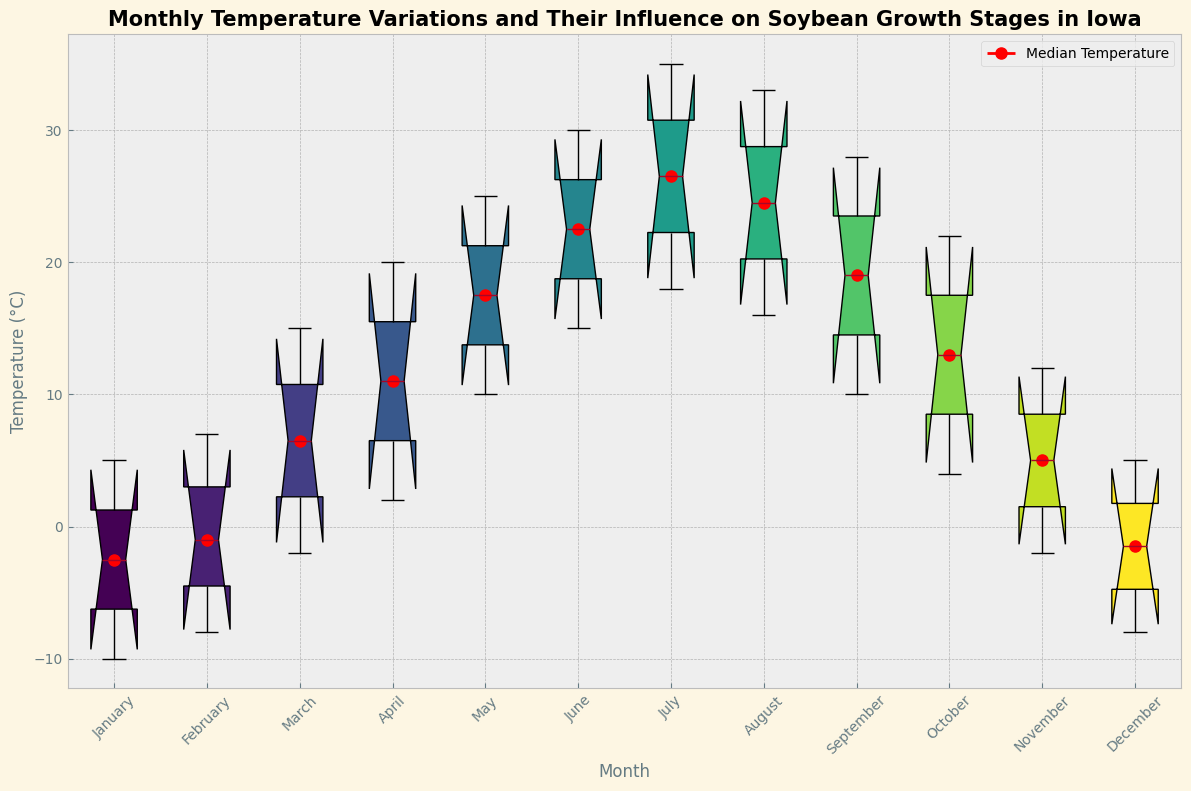What is the median temperature in July? The median temperature value can be directly found on the figure at the intersection of July and the red dot meant to indicate the median.
Answer: 26.5°C Which month has the highest maximum temperature, and what is that temperature? Look for the month with the highest point on the vertical axis corresponding to the box plot with the highest maximum box value.
Answer: July, 35.0°C In which month do the temperatures range from approximately -10°C to around 5°C? Identify the month with a box plot range showing minimum and maximum values spanning from about -10°C to 5°C.
Answer: January How does the temperature variation in June compare to that in September regarding the interquartile range (IQR)? The IQR is the range between the first quartile (bottom of the box) and the third quartile (top of the box). Evaluate the difference in the lengths of the boxes for June and September.
Answer: June has a larger IQR compared to September What is the impact on soybean growth stages for temperatures in March? Refer to the chart section specific to March and check the label or legend indicating the growth stage impact.
Answer: Early Vegetative Which month sees a drop in median temperature from August, and what is the new median temperature? Identify the months in order and compare the median values, marked by the red dots, from August to the following month.
Answer: September, 19.0°C Is the median temperature in April higher than that in October? Compare the positions of the red dots representing median temperatures for April and October.
Answer: Yes What is the approximate temperature range for the month of May? Check the lowest and highest points of the box for May to determine the temperature range.
Answer: 10.0°C to 25.0°C Which months are marked as having a "Dormant" impact on soybean growth stages? Locate and list months with the growth stage impact labeled as "Dormant" in the legend or directly on the chart.
Answer: January, February Do the temperature variations in Reproductive months appear to be wider than those in Pod Fill months? Observe the box lengths and overall ranges for the months labeled as "Reproductive" and compare them with those for "Pod Fill."
Answer: Yes 